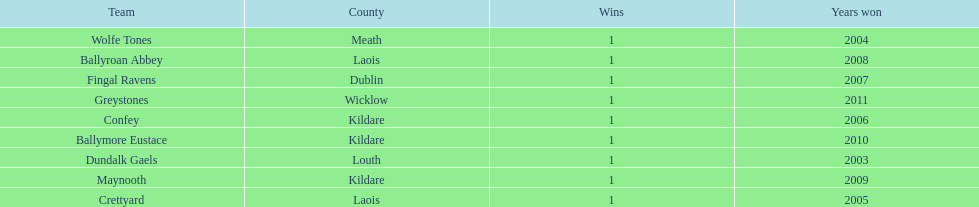What is the total of wins on the chart 9. 